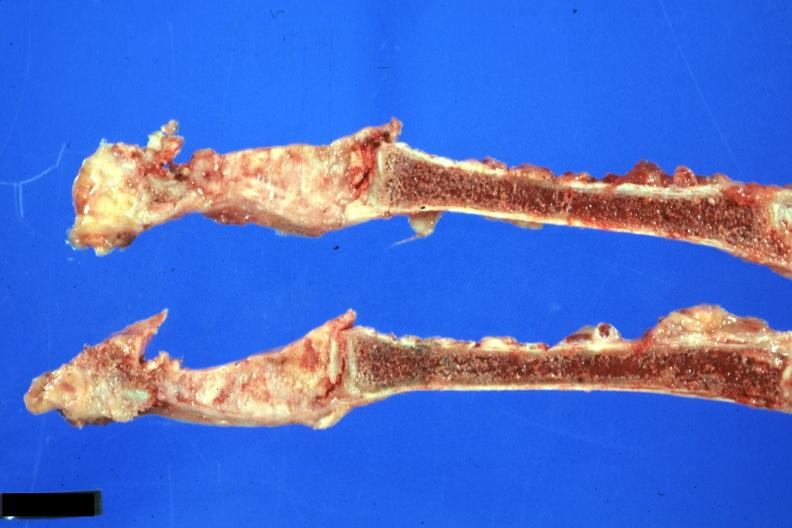what does this image show?
Answer the question using a single word or phrase. Sternum saggital section obvious neoplasm from lung scar carcinoma 